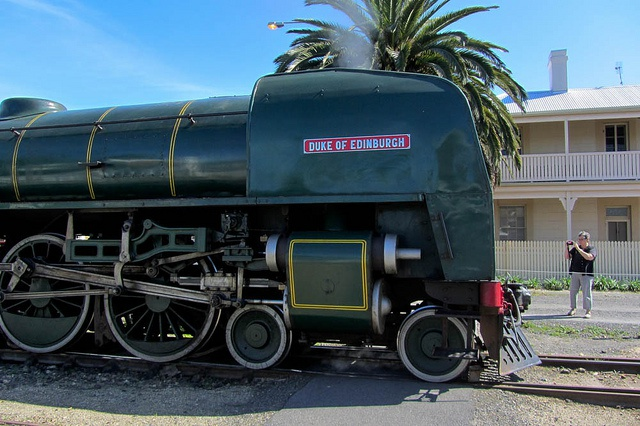Describe the objects in this image and their specific colors. I can see train in lightblue, black, blue, darkblue, and gray tones and people in lightblue, black, gray, and darkgray tones in this image. 